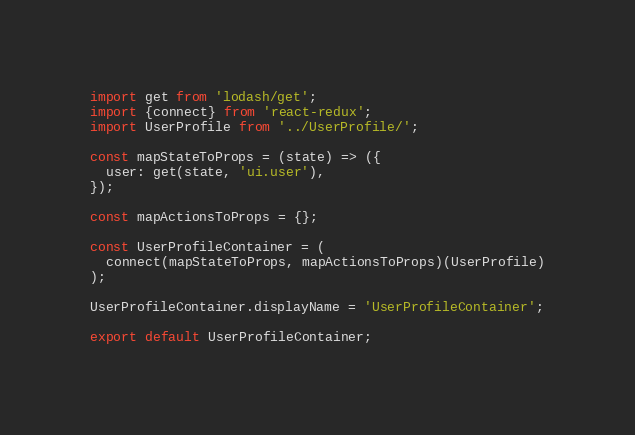Convert code to text. <code><loc_0><loc_0><loc_500><loc_500><_JavaScript_>import get from 'lodash/get';
import {connect} from 'react-redux';
import UserProfile from '../UserProfile/';

const mapStateToProps = (state) => ({
  user: get(state, 'ui.user'),
});

const mapActionsToProps = {};

const UserProfileContainer = (
  connect(mapStateToProps, mapActionsToProps)(UserProfile)
);

UserProfileContainer.displayName = 'UserProfileContainer';

export default UserProfileContainer;
</code> 